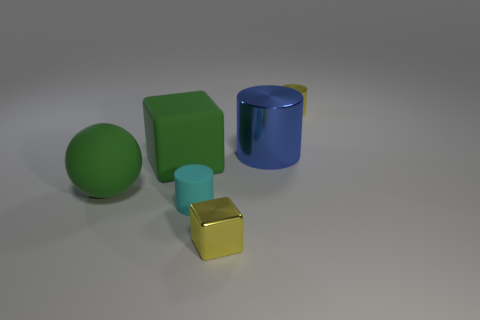There is a yellow shiny thing in front of the tiny rubber cylinder; is there a large matte ball in front of it?
Your answer should be very brief. No. What material is the other blue object that is the same shape as the small rubber object?
Your response must be concise. Metal. How many cylinders are right of the metal cylinder that is in front of the tiny yellow cylinder?
Make the answer very short. 1. Is there any other thing that has the same color as the sphere?
Ensure brevity in your answer.  Yes. How many objects are either cyan matte things or small shiny objects in front of the tiny yellow cylinder?
Make the answer very short. 2. There is a thing that is behind the metal cylinder that is in front of the small yellow object behind the tiny cyan matte cylinder; what is its material?
Keep it short and to the point. Metal. The yellow cylinder that is made of the same material as the blue object is what size?
Offer a very short reply. Small. What color is the matte thing in front of the green matte thing that is in front of the big green block?
Provide a short and direct response. Cyan. How many cylinders have the same material as the tiny yellow block?
Make the answer very short. 2. What number of matte objects are either yellow cubes or cubes?
Your response must be concise. 1. 